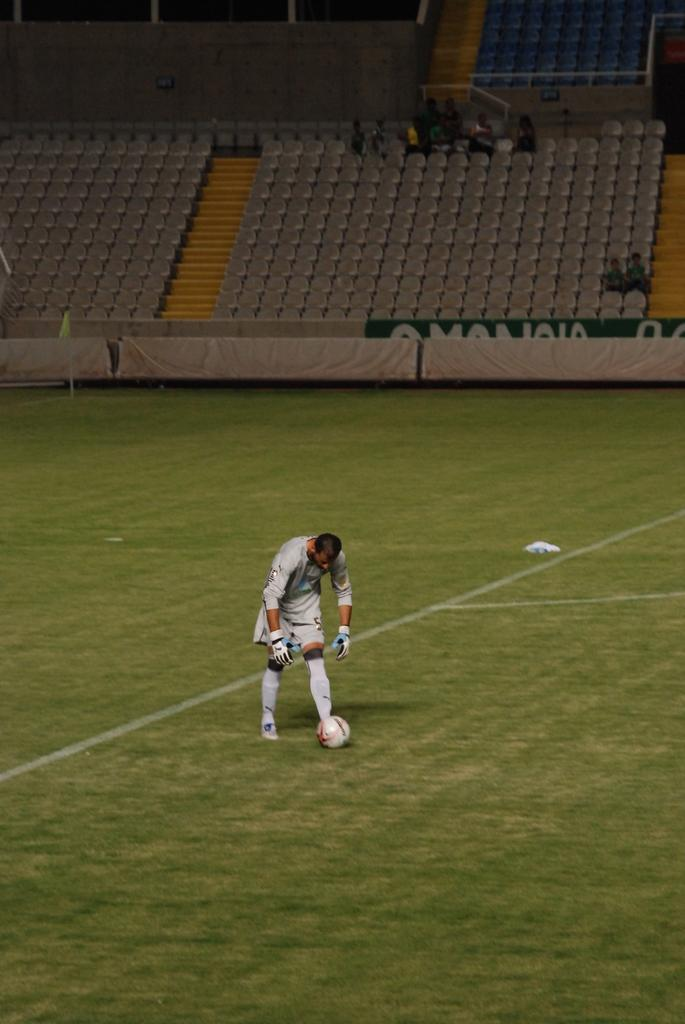What is the main subject in the image? There is a person standing in the image. What type of surface is the person standing on? There is grass in the image, which is the surface the person is standing on. What is the wall made of, and where is it located? There is a wall on the grass in the image, and it is made of an unspecified material. What other objects are visible in the image? There are boards and chairs visible in the image. What is behind the person in the image? There is another wall behind the person in the image. What type of flesh can be seen on the person in the image? There is no mention of flesh or any exposed body parts in the image; the person is fully clothed. What is the title of the image? There is no title provided for the image. 